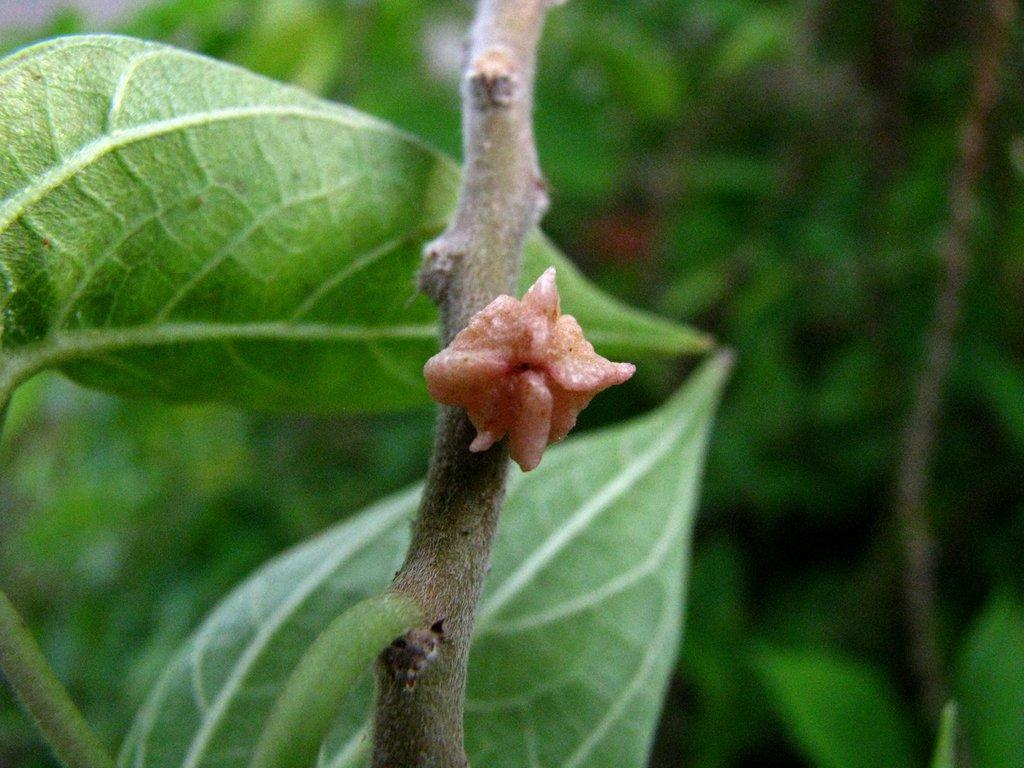What is the main subject of the image? The main subject of the image is a bud on a stem. Can you describe the location of the bud in the image? The bud is in the center of the image. What else can be seen in the background of the image? There are plants in the background of the image. What type of insurance policy is being discussed in the image? There is no mention of insurance in the image; it features a bud on a stem and plants in the background. 